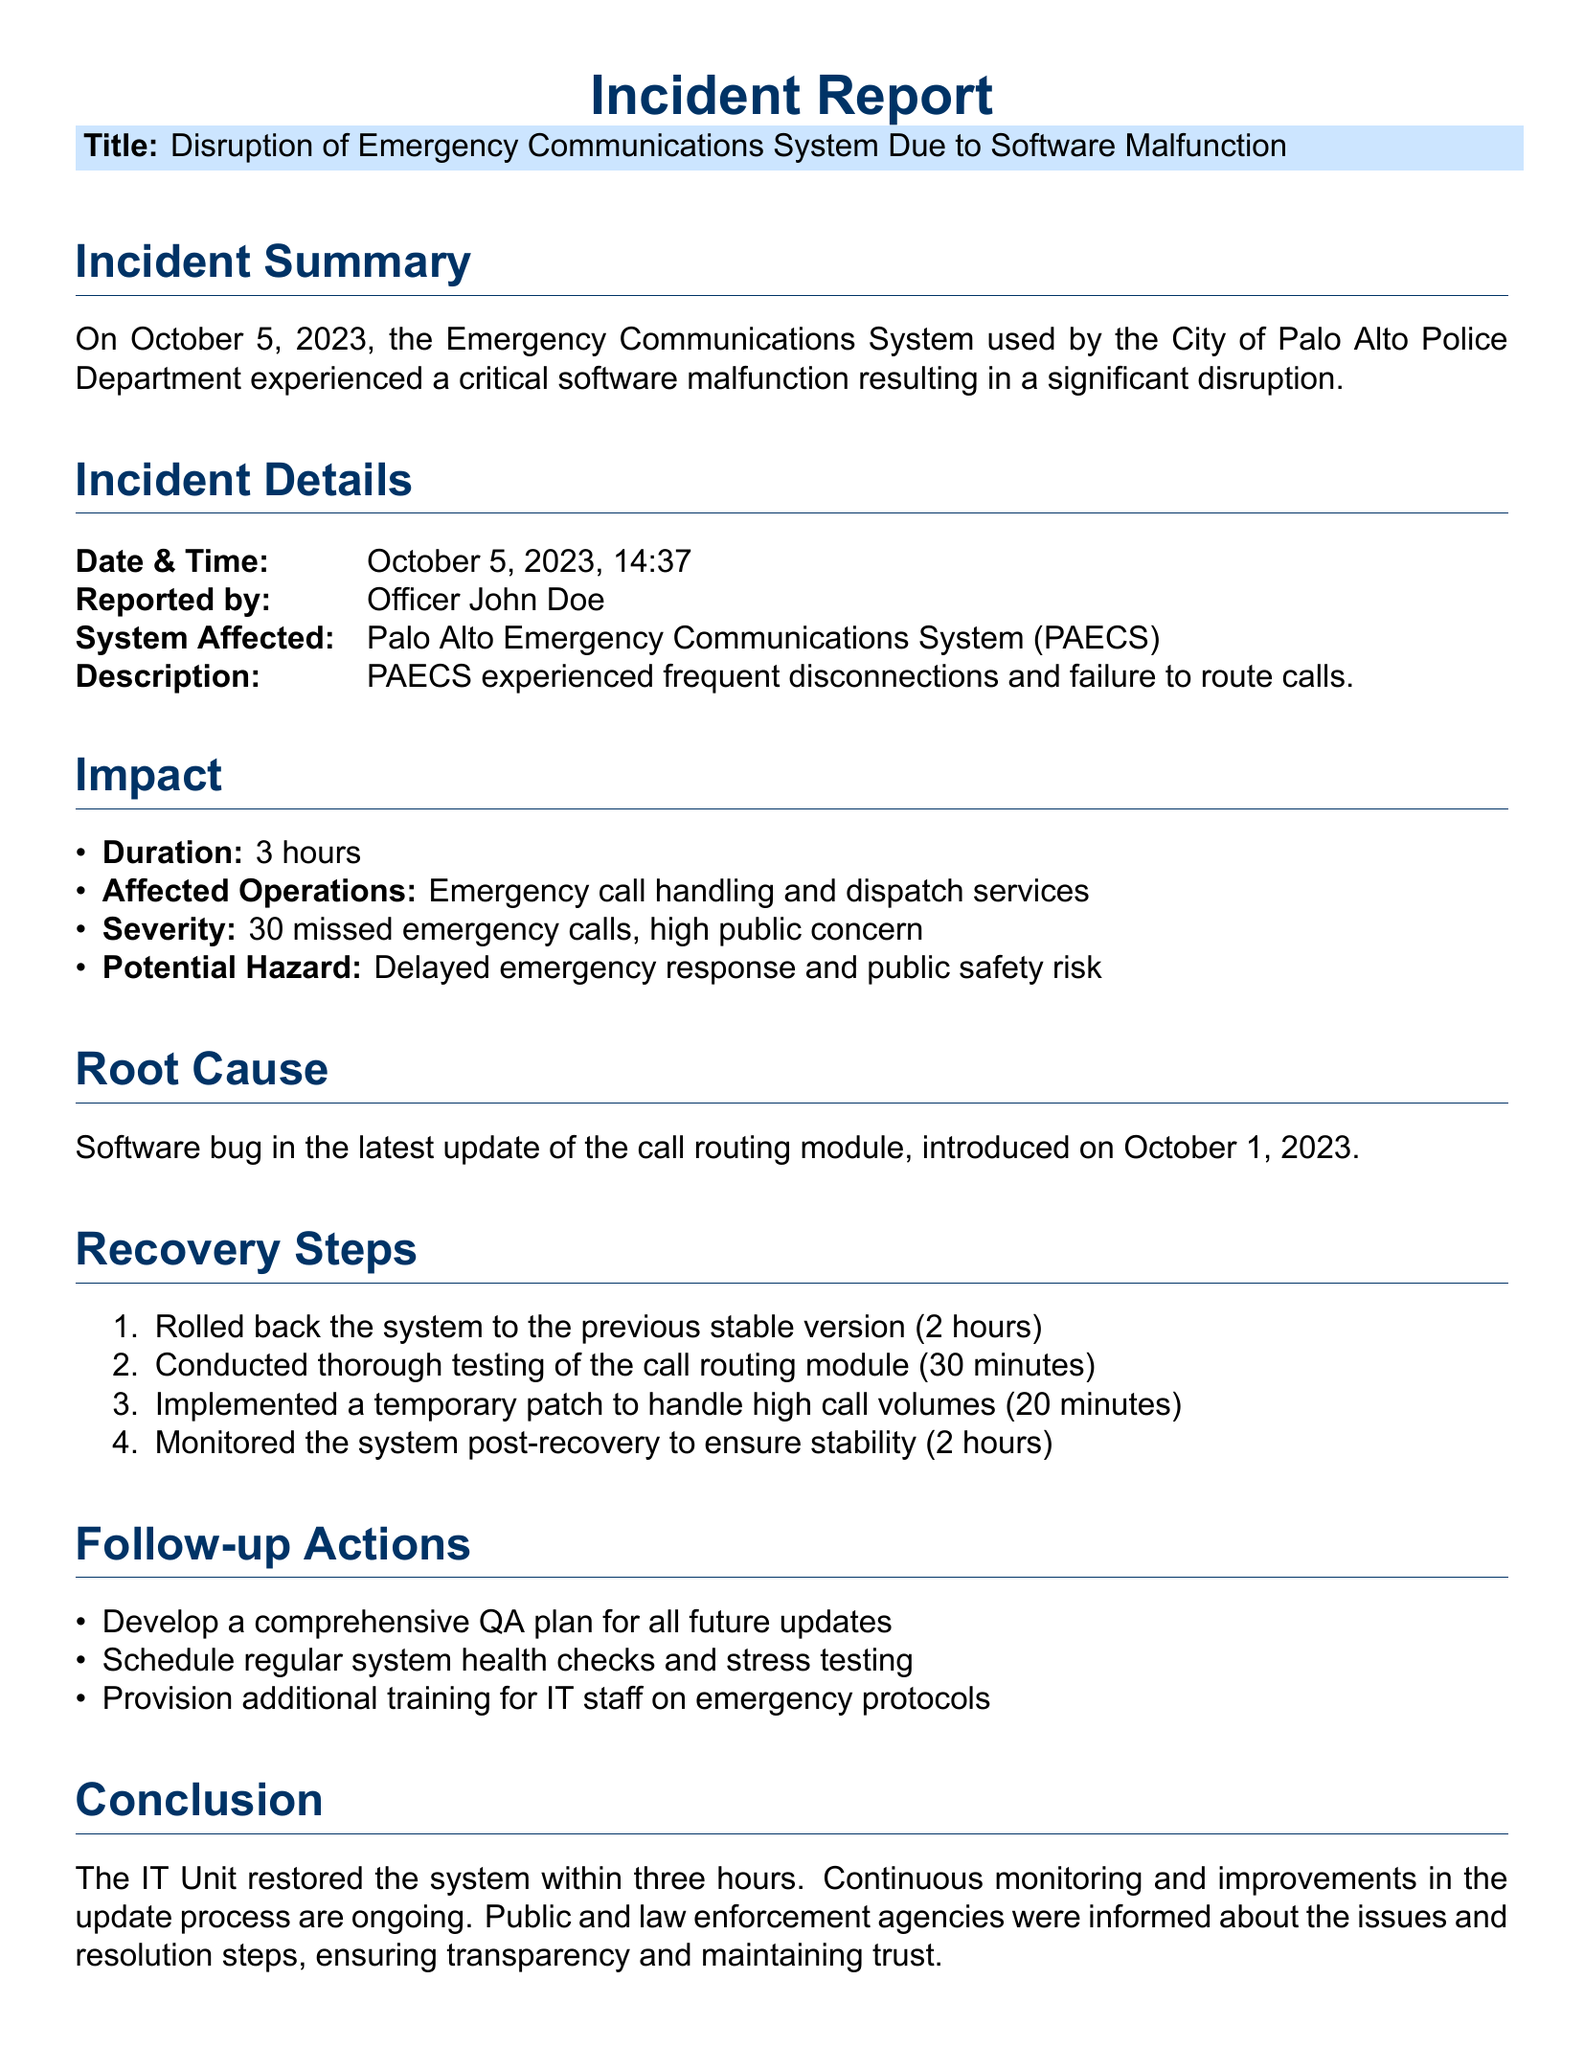What was the date of the incident? The date of the incident is specified in the incident details section of the document.
Answer: October 5, 2023 Who reported the incident? The name of the person who reported the incident is provided in the incident details section.
Answer: Officer John Doe How long did the disruption last? The duration of the disruption is mentioned in the impact section.
Answer: 3 hours What was the severity of the incident? The severity level of the incident is also listed in the impact section.
Answer: 30 missed emergency calls What was the root cause of the issue? The root cause is described in the corresponding section of the report.
Answer: Software bug How long did it take to roll back the system? The recovery steps section specifies the time taken to rollback the system.
Answer: 2 hours What action is suggested for future updates? The follow-up actions include developing a specific plan for updates.
Answer: comprehensive QA plan What was implemented to handle high call volumes? The recovery steps section describes the temporary solution used during the incident.
Answer: temporary patch What was the primary system affected? The incident details section mentions the system that experienced the malfunction.
Answer: Palo Alto Emergency Communications System (PAECS) 